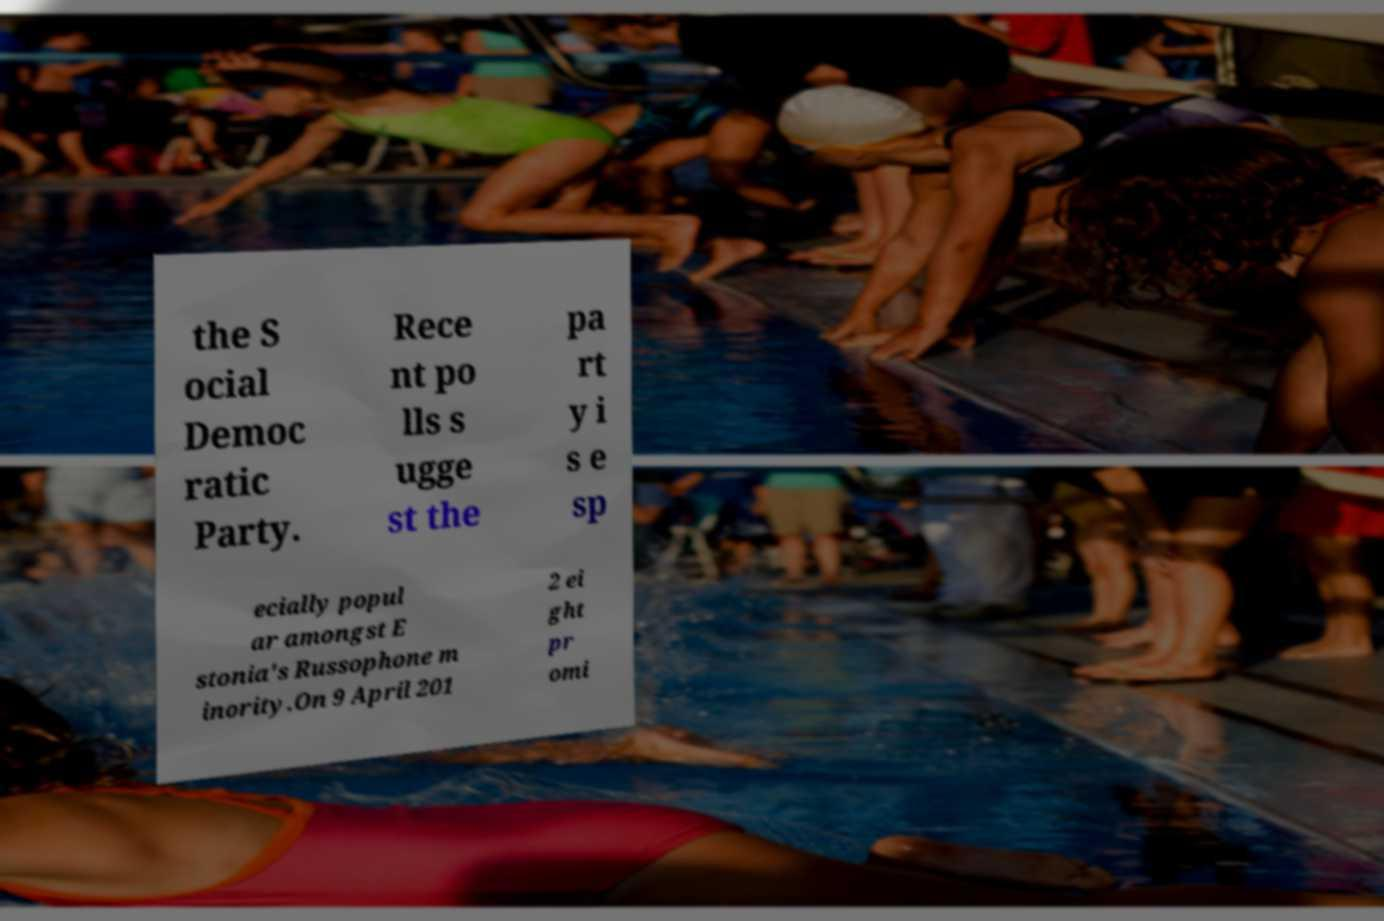I need the written content from this picture converted into text. Can you do that? the S ocial Democ ratic Party. Rece nt po lls s ugge st the pa rt y i s e sp ecially popul ar amongst E stonia's Russophone m inority.On 9 April 201 2 ei ght pr omi 